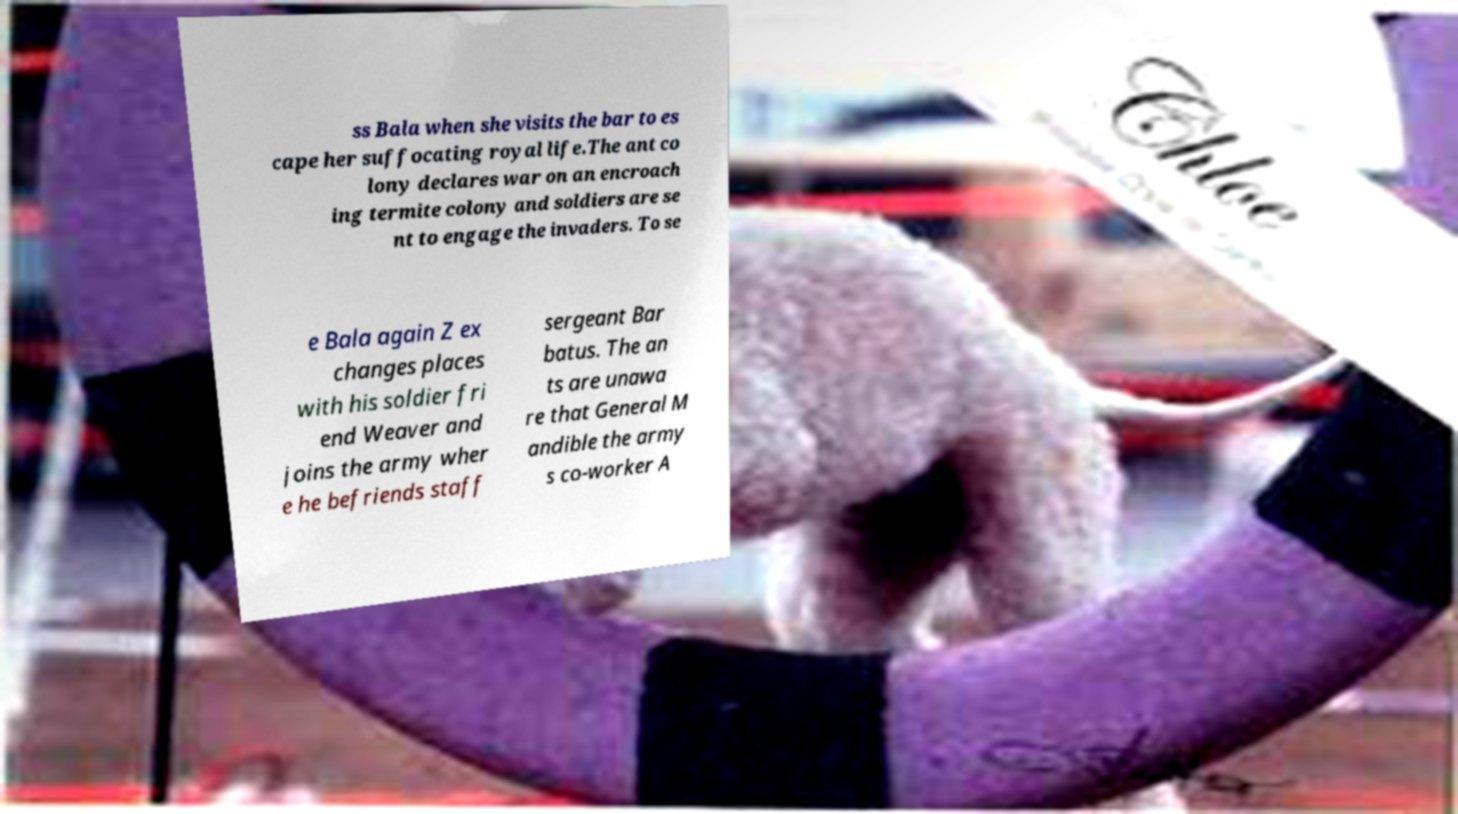Can you read and provide the text displayed in the image?This photo seems to have some interesting text. Can you extract and type it out for me? ss Bala when she visits the bar to es cape her suffocating royal life.The ant co lony declares war on an encroach ing termite colony and soldiers are se nt to engage the invaders. To se e Bala again Z ex changes places with his soldier fri end Weaver and joins the army wher e he befriends staff sergeant Bar batus. The an ts are unawa re that General M andible the army s co-worker A 